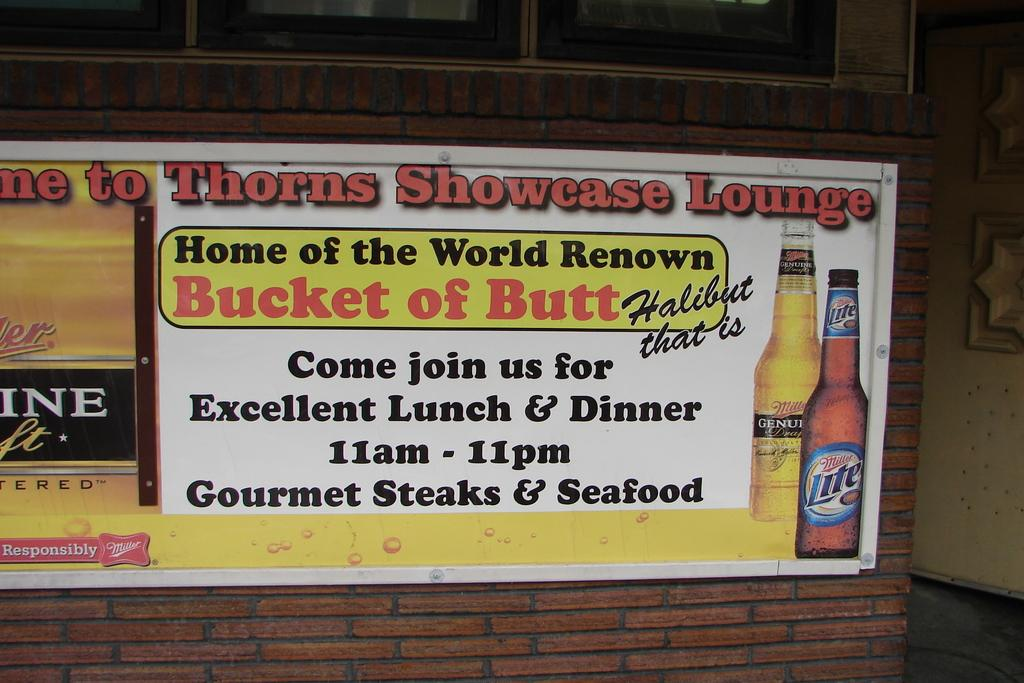<image>
Give a short and clear explanation of the subsequent image. An ad advertises gourmet steaks and seafood for lunch and dinner. 